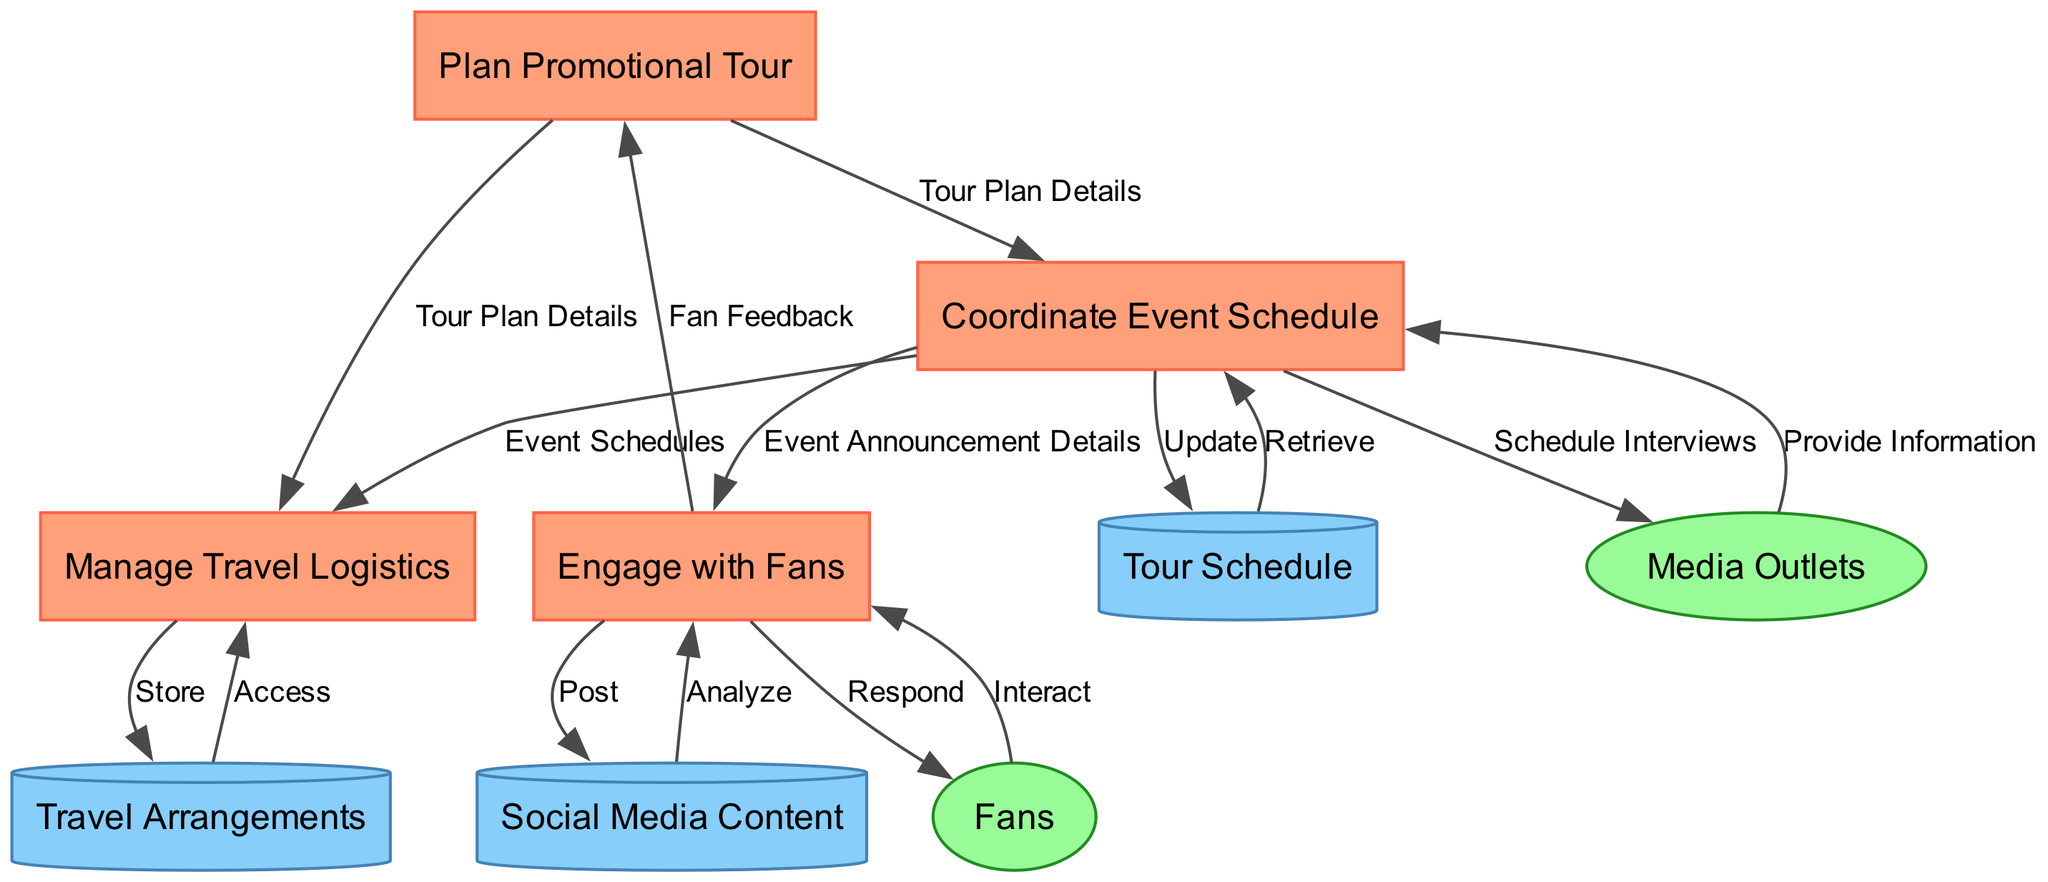What is the first process in the diagram? The first process listed in the diagram is "Plan Promotional Tour" which is identified as process 1.
Answer: Plan Promotional Tour How many processes are represented in the diagram? There are a total of four processes represented in the diagram.
Answer: 4 What type of node is "Travel Arrangements"? "Travel Arrangements" is classified as a data store in the diagram, depicted as a cylinder.
Answer: Data Store Which process receives "Event Schedules"? The "Manage Travel Logistics" process receives "Event Schedules," which flows from the "Coordinate Event Schedule" process.
Answer: Manage Travel Logistics What information flows from "Fans" to "Engage with Fans"? The data flowing from "Fans" to "Engage with Fans" is labeled as "Interact."
Answer: Interact How does the "Coordinate Event Schedule" process interact with "Media Outlets"? The "Coordinate Event Schedule" process provides "Schedule Interviews" to "Media Outlets", indicating a communication flow from the process to the external entity.
Answer: Schedule Interviews Which data store is updated by the "Coordinate Event Schedule" process? The "Tour Schedule" data store is updated by the "Coordinate Event Schedule" process, indicating that event information is stored there.
Answer: Tour Schedule How many edges are there in total connecting processes? There are six edges connecting various processes in the diagram, illustrating the data flows between them.
Answer: 6 What type of node is "Fans" classified as? "Fans" is classified as an external entity in the diagram, represented as an ellipse.
Answer: External Entity Which data store is accessed by the "Manage Travel Logistics" process? The "Travel Arrangements" data store is accessed by the "Manage Travel Logistics" process for retrieving travel-related information.
Answer: Travel Arrangements 